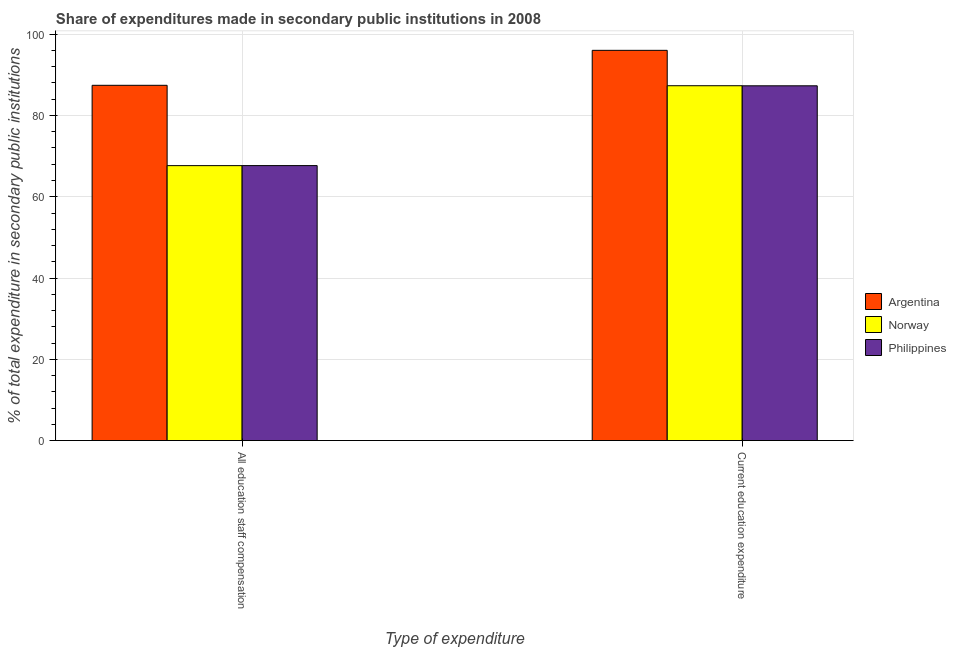What is the label of the 2nd group of bars from the left?
Keep it short and to the point. Current education expenditure. What is the expenditure in staff compensation in Philippines?
Your answer should be compact. 67.67. Across all countries, what is the maximum expenditure in staff compensation?
Offer a terse response. 87.43. Across all countries, what is the minimum expenditure in staff compensation?
Keep it short and to the point. 67.66. In which country was the expenditure in education maximum?
Make the answer very short. Argentina. What is the total expenditure in staff compensation in the graph?
Offer a terse response. 222.75. What is the difference between the expenditure in staff compensation in Argentina and that in Norway?
Ensure brevity in your answer.  19.77. What is the difference between the expenditure in education in Norway and the expenditure in staff compensation in Philippines?
Your answer should be compact. 19.66. What is the average expenditure in education per country?
Give a very brief answer. 90.22. What is the difference between the expenditure in education and expenditure in staff compensation in Argentina?
Provide a short and direct response. 8.61. In how many countries, is the expenditure in staff compensation greater than 76 %?
Offer a terse response. 1. What is the ratio of the expenditure in staff compensation in Norway to that in Argentina?
Offer a very short reply. 0.77. Is the expenditure in education in Argentina less than that in Norway?
Your answer should be very brief. No. What does the 3rd bar from the left in All education staff compensation represents?
Your response must be concise. Philippines. How many bars are there?
Offer a terse response. 6. Are all the bars in the graph horizontal?
Offer a very short reply. No. Does the graph contain grids?
Keep it short and to the point. Yes. Where does the legend appear in the graph?
Offer a very short reply. Center right. How many legend labels are there?
Your answer should be compact. 3. What is the title of the graph?
Offer a terse response. Share of expenditures made in secondary public institutions in 2008. What is the label or title of the X-axis?
Provide a succinct answer. Type of expenditure. What is the label or title of the Y-axis?
Offer a very short reply. % of total expenditure in secondary public institutions. What is the % of total expenditure in secondary public institutions in Argentina in All education staff compensation?
Offer a very short reply. 87.43. What is the % of total expenditure in secondary public institutions in Norway in All education staff compensation?
Your answer should be compact. 67.66. What is the % of total expenditure in secondary public institutions of Philippines in All education staff compensation?
Make the answer very short. 67.67. What is the % of total expenditure in secondary public institutions in Argentina in Current education expenditure?
Ensure brevity in your answer.  96.03. What is the % of total expenditure in secondary public institutions in Norway in Current education expenditure?
Your answer should be very brief. 87.32. What is the % of total expenditure in secondary public institutions in Philippines in Current education expenditure?
Your answer should be compact. 87.3. Across all Type of expenditure, what is the maximum % of total expenditure in secondary public institutions of Argentina?
Provide a short and direct response. 96.03. Across all Type of expenditure, what is the maximum % of total expenditure in secondary public institutions of Norway?
Give a very brief answer. 87.32. Across all Type of expenditure, what is the maximum % of total expenditure in secondary public institutions in Philippines?
Give a very brief answer. 87.3. Across all Type of expenditure, what is the minimum % of total expenditure in secondary public institutions in Argentina?
Provide a short and direct response. 87.43. Across all Type of expenditure, what is the minimum % of total expenditure in secondary public institutions of Norway?
Your answer should be compact. 67.66. Across all Type of expenditure, what is the minimum % of total expenditure in secondary public institutions of Philippines?
Give a very brief answer. 67.67. What is the total % of total expenditure in secondary public institutions of Argentina in the graph?
Provide a short and direct response. 183.46. What is the total % of total expenditure in secondary public institutions in Norway in the graph?
Offer a very short reply. 154.98. What is the total % of total expenditure in secondary public institutions of Philippines in the graph?
Give a very brief answer. 154.97. What is the difference between the % of total expenditure in secondary public institutions in Argentina in All education staff compensation and that in Current education expenditure?
Keep it short and to the point. -8.61. What is the difference between the % of total expenditure in secondary public institutions in Norway in All education staff compensation and that in Current education expenditure?
Offer a very short reply. -19.67. What is the difference between the % of total expenditure in secondary public institutions in Philippines in All education staff compensation and that in Current education expenditure?
Offer a terse response. -19.64. What is the difference between the % of total expenditure in secondary public institutions in Argentina in All education staff compensation and the % of total expenditure in secondary public institutions in Norway in Current education expenditure?
Provide a short and direct response. 0.1. What is the difference between the % of total expenditure in secondary public institutions in Argentina in All education staff compensation and the % of total expenditure in secondary public institutions in Philippines in Current education expenditure?
Offer a very short reply. 0.12. What is the difference between the % of total expenditure in secondary public institutions of Norway in All education staff compensation and the % of total expenditure in secondary public institutions of Philippines in Current education expenditure?
Ensure brevity in your answer.  -19.65. What is the average % of total expenditure in secondary public institutions of Argentina per Type of expenditure?
Give a very brief answer. 91.73. What is the average % of total expenditure in secondary public institutions of Norway per Type of expenditure?
Your response must be concise. 77.49. What is the average % of total expenditure in secondary public institutions of Philippines per Type of expenditure?
Offer a very short reply. 77.49. What is the difference between the % of total expenditure in secondary public institutions of Argentina and % of total expenditure in secondary public institutions of Norway in All education staff compensation?
Your answer should be very brief. 19.77. What is the difference between the % of total expenditure in secondary public institutions in Argentina and % of total expenditure in secondary public institutions in Philippines in All education staff compensation?
Give a very brief answer. 19.76. What is the difference between the % of total expenditure in secondary public institutions in Norway and % of total expenditure in secondary public institutions in Philippines in All education staff compensation?
Make the answer very short. -0.01. What is the difference between the % of total expenditure in secondary public institutions in Argentina and % of total expenditure in secondary public institutions in Norway in Current education expenditure?
Give a very brief answer. 8.71. What is the difference between the % of total expenditure in secondary public institutions of Argentina and % of total expenditure in secondary public institutions of Philippines in Current education expenditure?
Offer a terse response. 8.73. What is the difference between the % of total expenditure in secondary public institutions of Norway and % of total expenditure in secondary public institutions of Philippines in Current education expenditure?
Give a very brief answer. 0.02. What is the ratio of the % of total expenditure in secondary public institutions in Argentina in All education staff compensation to that in Current education expenditure?
Keep it short and to the point. 0.91. What is the ratio of the % of total expenditure in secondary public institutions in Norway in All education staff compensation to that in Current education expenditure?
Your response must be concise. 0.77. What is the ratio of the % of total expenditure in secondary public institutions of Philippines in All education staff compensation to that in Current education expenditure?
Your answer should be very brief. 0.78. What is the difference between the highest and the second highest % of total expenditure in secondary public institutions in Argentina?
Give a very brief answer. 8.61. What is the difference between the highest and the second highest % of total expenditure in secondary public institutions of Norway?
Keep it short and to the point. 19.67. What is the difference between the highest and the second highest % of total expenditure in secondary public institutions in Philippines?
Your response must be concise. 19.64. What is the difference between the highest and the lowest % of total expenditure in secondary public institutions in Argentina?
Provide a succinct answer. 8.61. What is the difference between the highest and the lowest % of total expenditure in secondary public institutions of Norway?
Offer a terse response. 19.67. What is the difference between the highest and the lowest % of total expenditure in secondary public institutions in Philippines?
Make the answer very short. 19.64. 